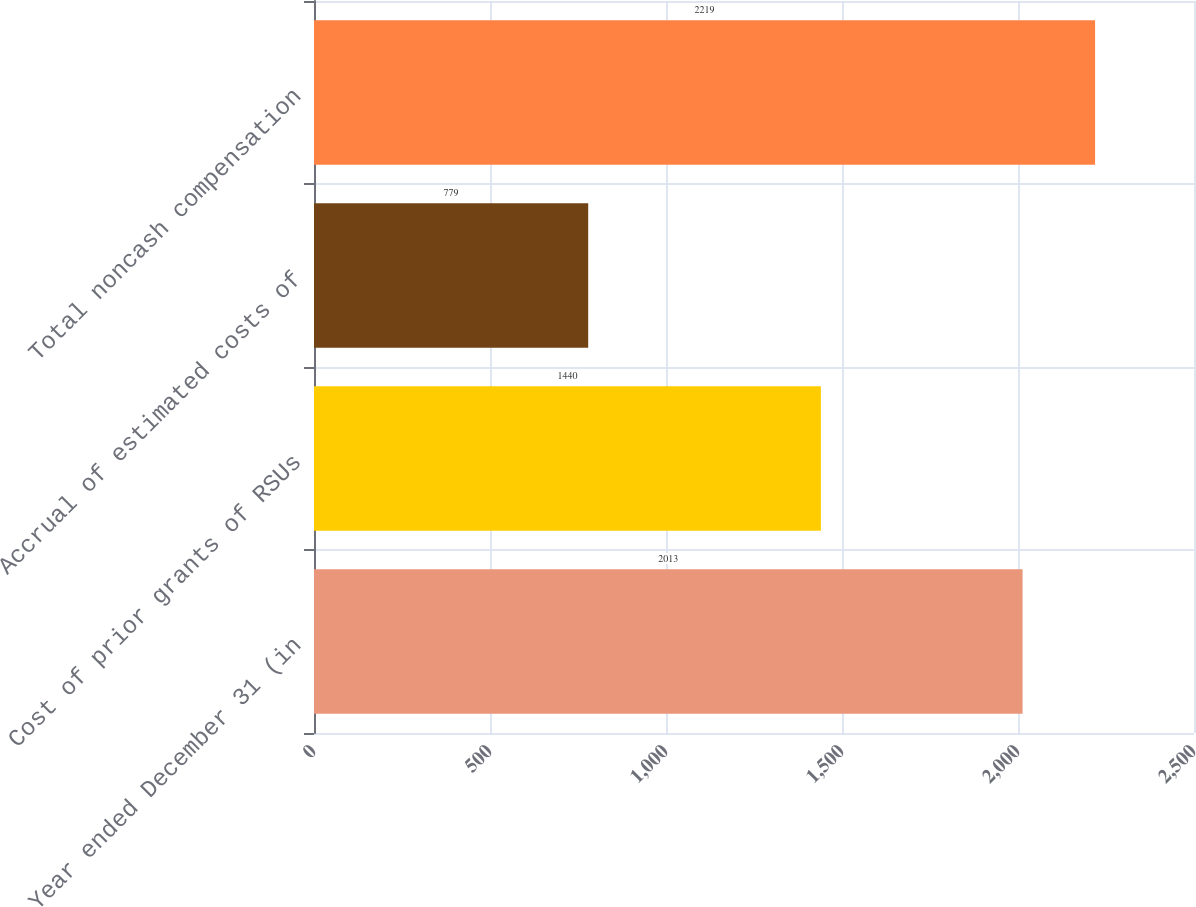<chart> <loc_0><loc_0><loc_500><loc_500><bar_chart><fcel>Year ended December 31 (in<fcel>Cost of prior grants of RSUs<fcel>Accrual of estimated costs of<fcel>Total noncash compensation<nl><fcel>2013<fcel>1440<fcel>779<fcel>2219<nl></chart> 